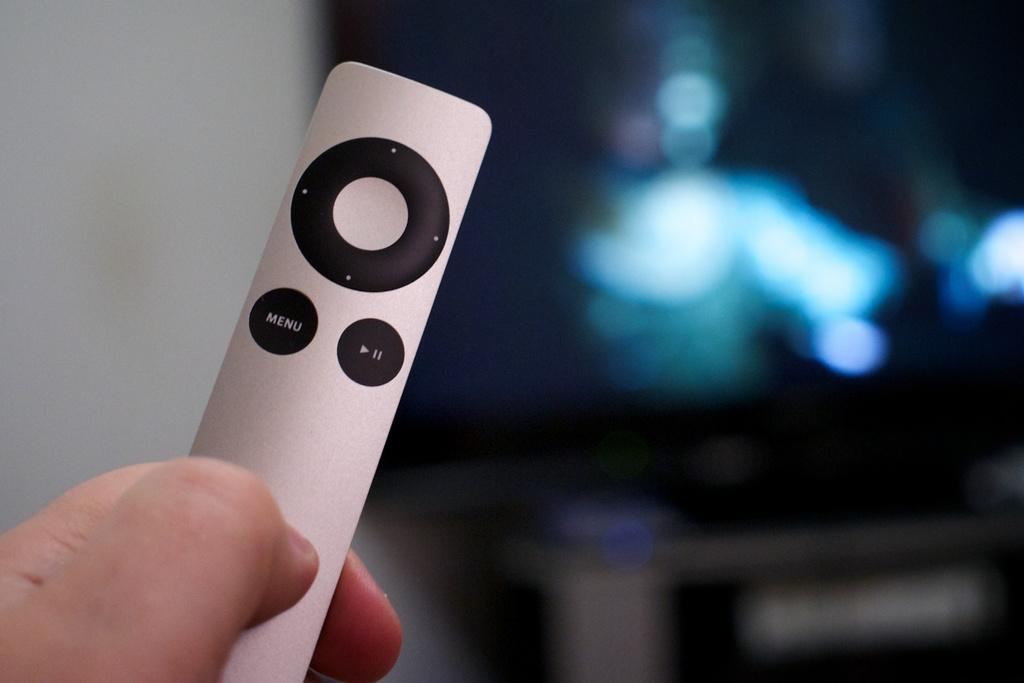<image>
Write a terse but informative summary of the picture. an iPod that has a menu button on it 